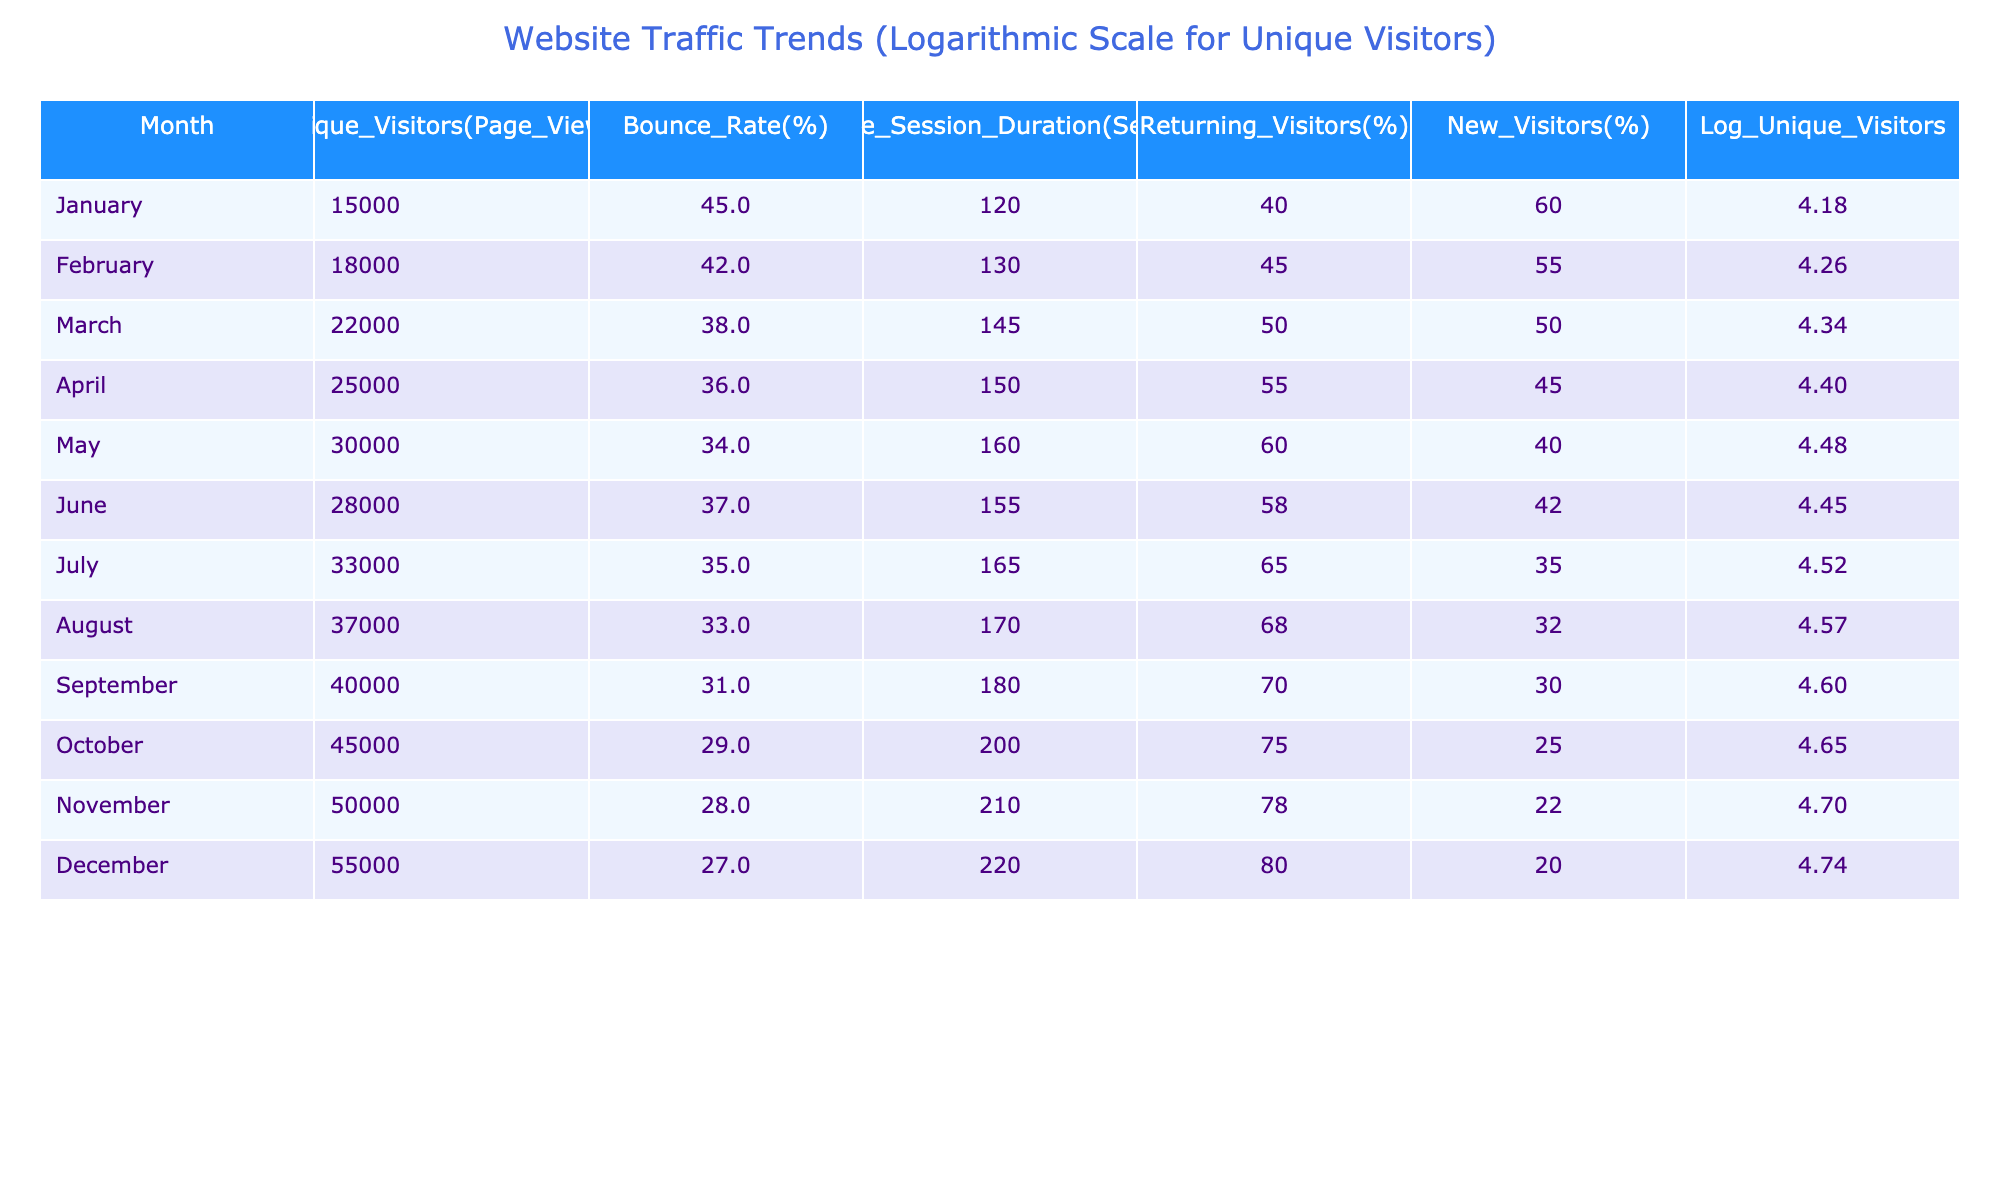What was the unique visitors count in December? The unique visitors for December is directly listed in the table under the "Unique_Visitors(Page_Views)" column for that month. According to the data, December had 55,000 unique visitors.
Answer: 55,000 Which month had the highest bounce rate and what was it? By examining the "Bounce_Rate(%)" column for all months, the highest bounce rate is found in January at 45%.
Answer: 45% What is the average session duration for the first half of the year (January to June)? We will sum the average session durations from January to June and divide by the number of months. The total is (120 + 130 + 145 + 150 + 160 + 155) = 960 seconds. There are 6 months, so the average is 960/6 = 160 seconds.
Answer: 160 How many unique visitors did the blog gain from January to December? To find the total unique visitors gained, we need to sum the unique visitors of each month from January to December, which equals (15000 + 18000 + 22000 + 25000 + 30000 + 28000 + 33000 + 37000 + 40000 + 45000 + 50000 + 55000) = 396000.
Answer: 396,000 Is the proportion of returning visitors greater than 50% in August? In the table, the returning visitors percentage for August is recorded as 68%, which exceeds 50%. Therefore, the statement is true.
Answer: Yes In which month did the session duration exceed 200 seconds? Looking at the "Average_Session_Duration(Seconds)" column, we find that no month has a session duration over 200 seconds, so the answer is that it never exceeded that amount.
Answer: No What is the difference in unique visitors between January and July? To find the difference, we subtract the unique visitors in January (15000) from those in July (33000). Thus the difference is 33000 - 15000 = 18000.
Answer: 18,000 What was the percentage of new visitors in October? The table shows that for October, the percentage of new visitors is listed as 25%. This is a direct retrieval from the table.
Answer: 25% 